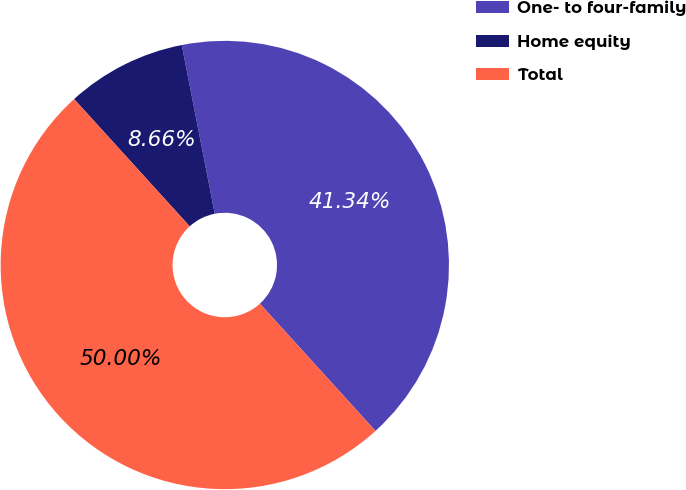<chart> <loc_0><loc_0><loc_500><loc_500><pie_chart><fcel>One- to four-family<fcel>Home equity<fcel>Total<nl><fcel>41.34%<fcel>8.66%<fcel>50.0%<nl></chart> 